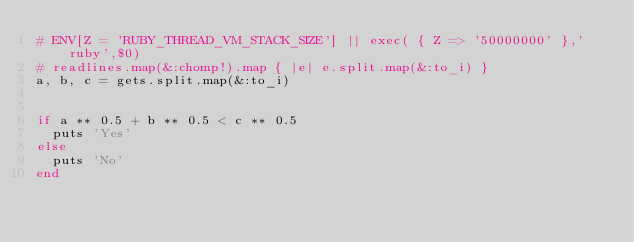Convert code to text. <code><loc_0><loc_0><loc_500><loc_500><_Ruby_># ENV[Z = 'RUBY_THREAD_VM_STACK_SIZE'] || exec( { Z => '50000000' },'ruby',$0)
# readlines.map(&:chomp!).map { |e| e.split.map(&:to_i) }
a, b, c = gets.split.map(&:to_i)


if a ** 0.5 + b ** 0.5 < c ** 0.5
  puts 'Yes'
else
  puts 'No'
end
</code> 